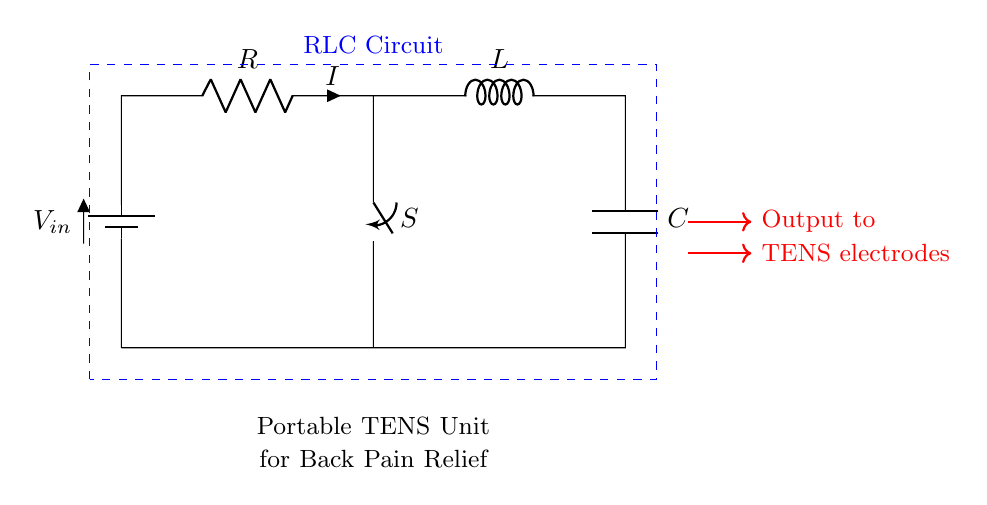What is the power source in this circuit? The power source is indicated as a battery, labeled V in the circuit diagram. It is the source that provides electrical energy to the circuit.
Answer: battery What component controls the current flow in the circuit? The component that controls the current flow is the switch, labeled S. When the switch is closed, it allows current to flow; when it's open, it stops the current.
Answer: switch What is the role of the inductor in this circuit? The inductor, labeled L, stores energy in a magnetic field when current flows through it. In this RLC circuit, it plays a critical role in controlling the energy dynamics.
Answer: store energy How many main components are present in the circuit? The circuit contains three main components, namely the resistor, inductor, and capacitor, which are essential in any RLC circuit.
Answer: three What does the switch position indicate about the circuit status? The switch position indicates whether the circuit is 'open' or 'closed.' If closed, it completes the circuit allowing current to flow; if open, it breaks the circuit.
Answer: circuit status What type of circuit is represented here? The circuit is classified as a series RLC circuit since the resistor, inductor, and capacitor are connected in series configuration.
Answer: series RLC circuit 